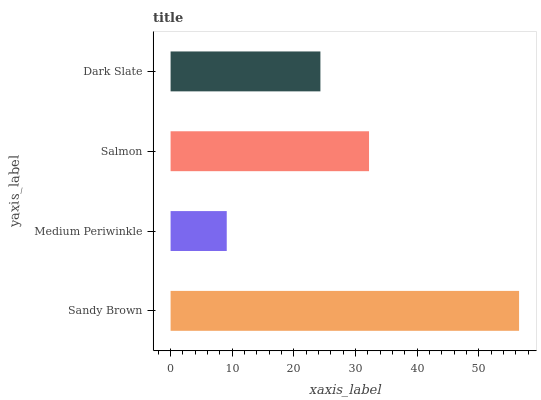Is Medium Periwinkle the minimum?
Answer yes or no. Yes. Is Sandy Brown the maximum?
Answer yes or no. Yes. Is Salmon the minimum?
Answer yes or no. No. Is Salmon the maximum?
Answer yes or no. No. Is Salmon greater than Medium Periwinkle?
Answer yes or no. Yes. Is Medium Periwinkle less than Salmon?
Answer yes or no. Yes. Is Medium Periwinkle greater than Salmon?
Answer yes or no. No. Is Salmon less than Medium Periwinkle?
Answer yes or no. No. Is Salmon the high median?
Answer yes or no. Yes. Is Dark Slate the low median?
Answer yes or no. Yes. Is Medium Periwinkle the high median?
Answer yes or no. No. Is Salmon the low median?
Answer yes or no. No. 